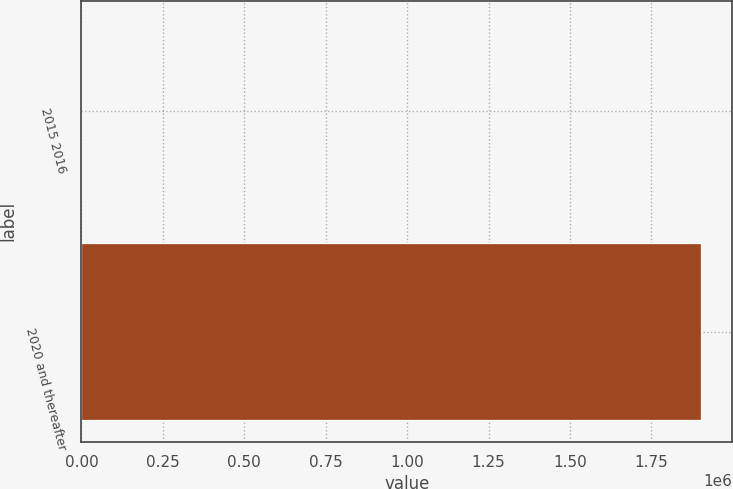Convert chart to OTSL. <chart><loc_0><loc_0><loc_500><loc_500><bar_chart><fcel>2015 2016<fcel>2020 and thereafter<nl><fcel>114<fcel>1.90385e+06<nl></chart> 